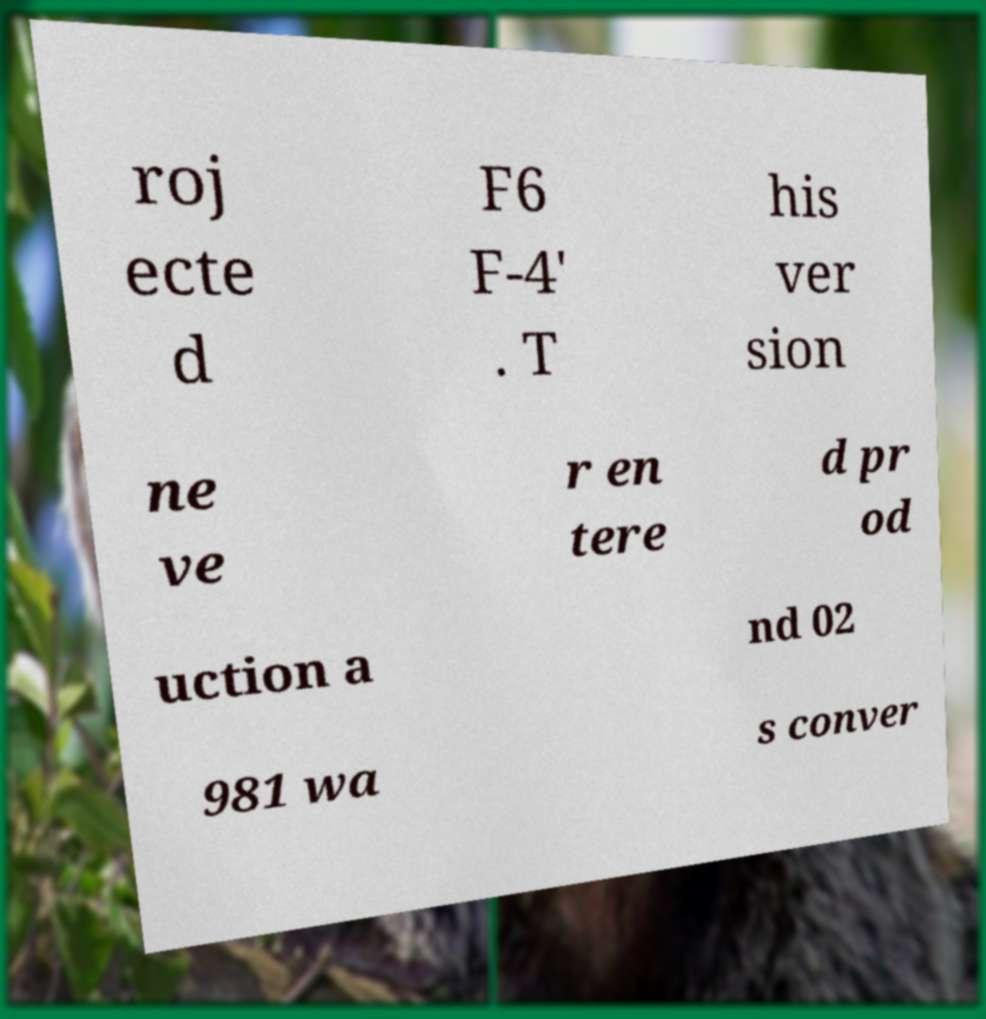For documentation purposes, I need the text within this image transcribed. Could you provide that? roj ecte d F6 F-4' . T his ver sion ne ve r en tere d pr od uction a nd 02 981 wa s conver 